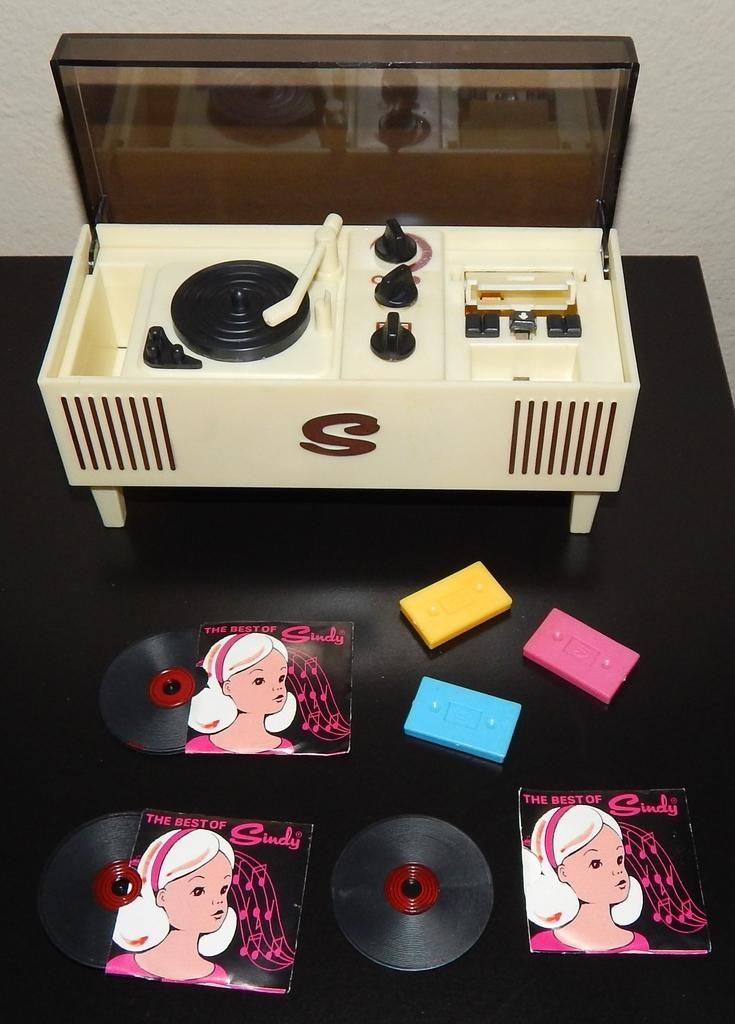<image>
Offer a succinct explanation of the picture presented. Three albums are called "The Best of Sindy." 